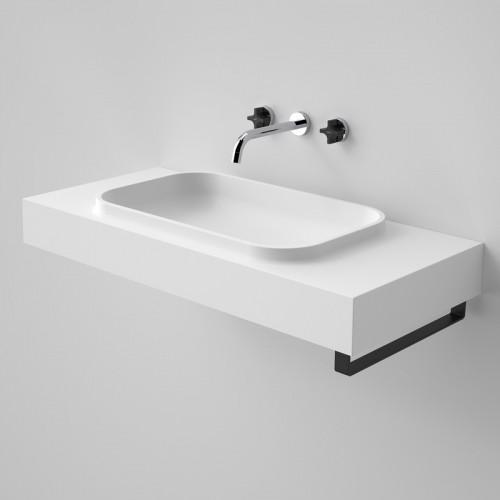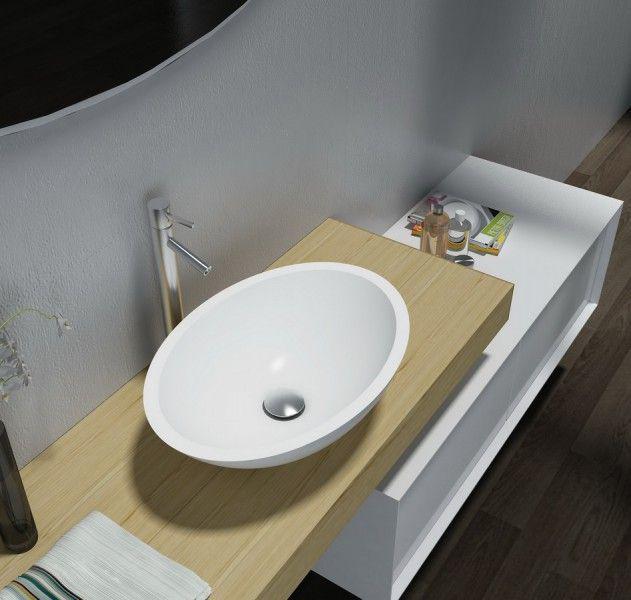The first image is the image on the left, the second image is the image on the right. Given the left and right images, does the statement "Each image shows a white bowl-shaped sink that sits on top of a counter." hold true? Answer yes or no. No. 